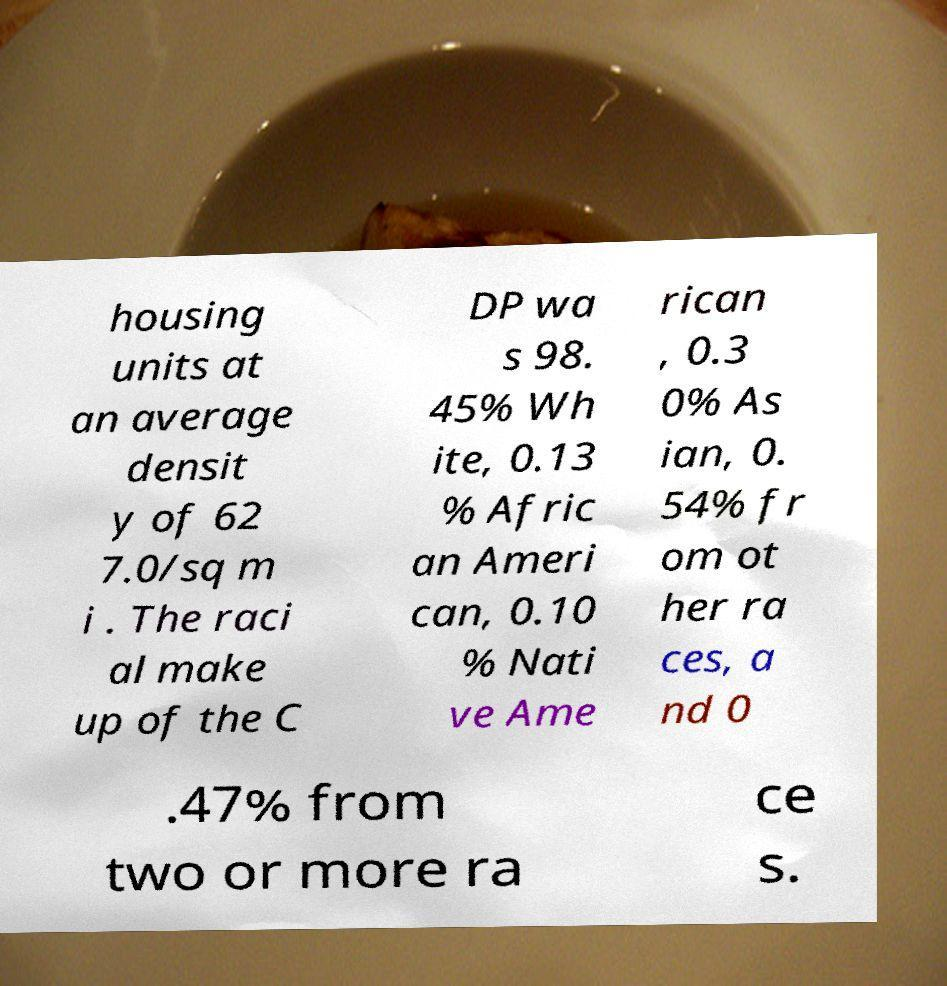Could you extract and type out the text from this image? housing units at an average densit y of 62 7.0/sq m i . The raci al make up of the C DP wa s 98. 45% Wh ite, 0.13 % Afric an Ameri can, 0.10 % Nati ve Ame rican , 0.3 0% As ian, 0. 54% fr om ot her ra ces, a nd 0 .47% from two or more ra ce s. 